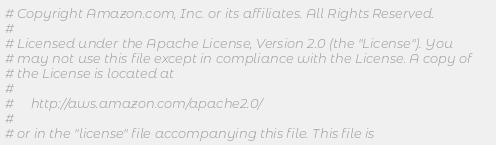Convert code to text. <code><loc_0><loc_0><loc_500><loc_500><_Python_># Copyright Amazon.com, Inc. or its affiliates. All Rights Reserved.
#
# Licensed under the Apache License, Version 2.0 (the "License"). You
# may not use this file except in compliance with the License. A copy of
# the License is located at
#
#     http://aws.amazon.com/apache2.0/
#
# or in the "license" file accompanying this file. This file is</code> 